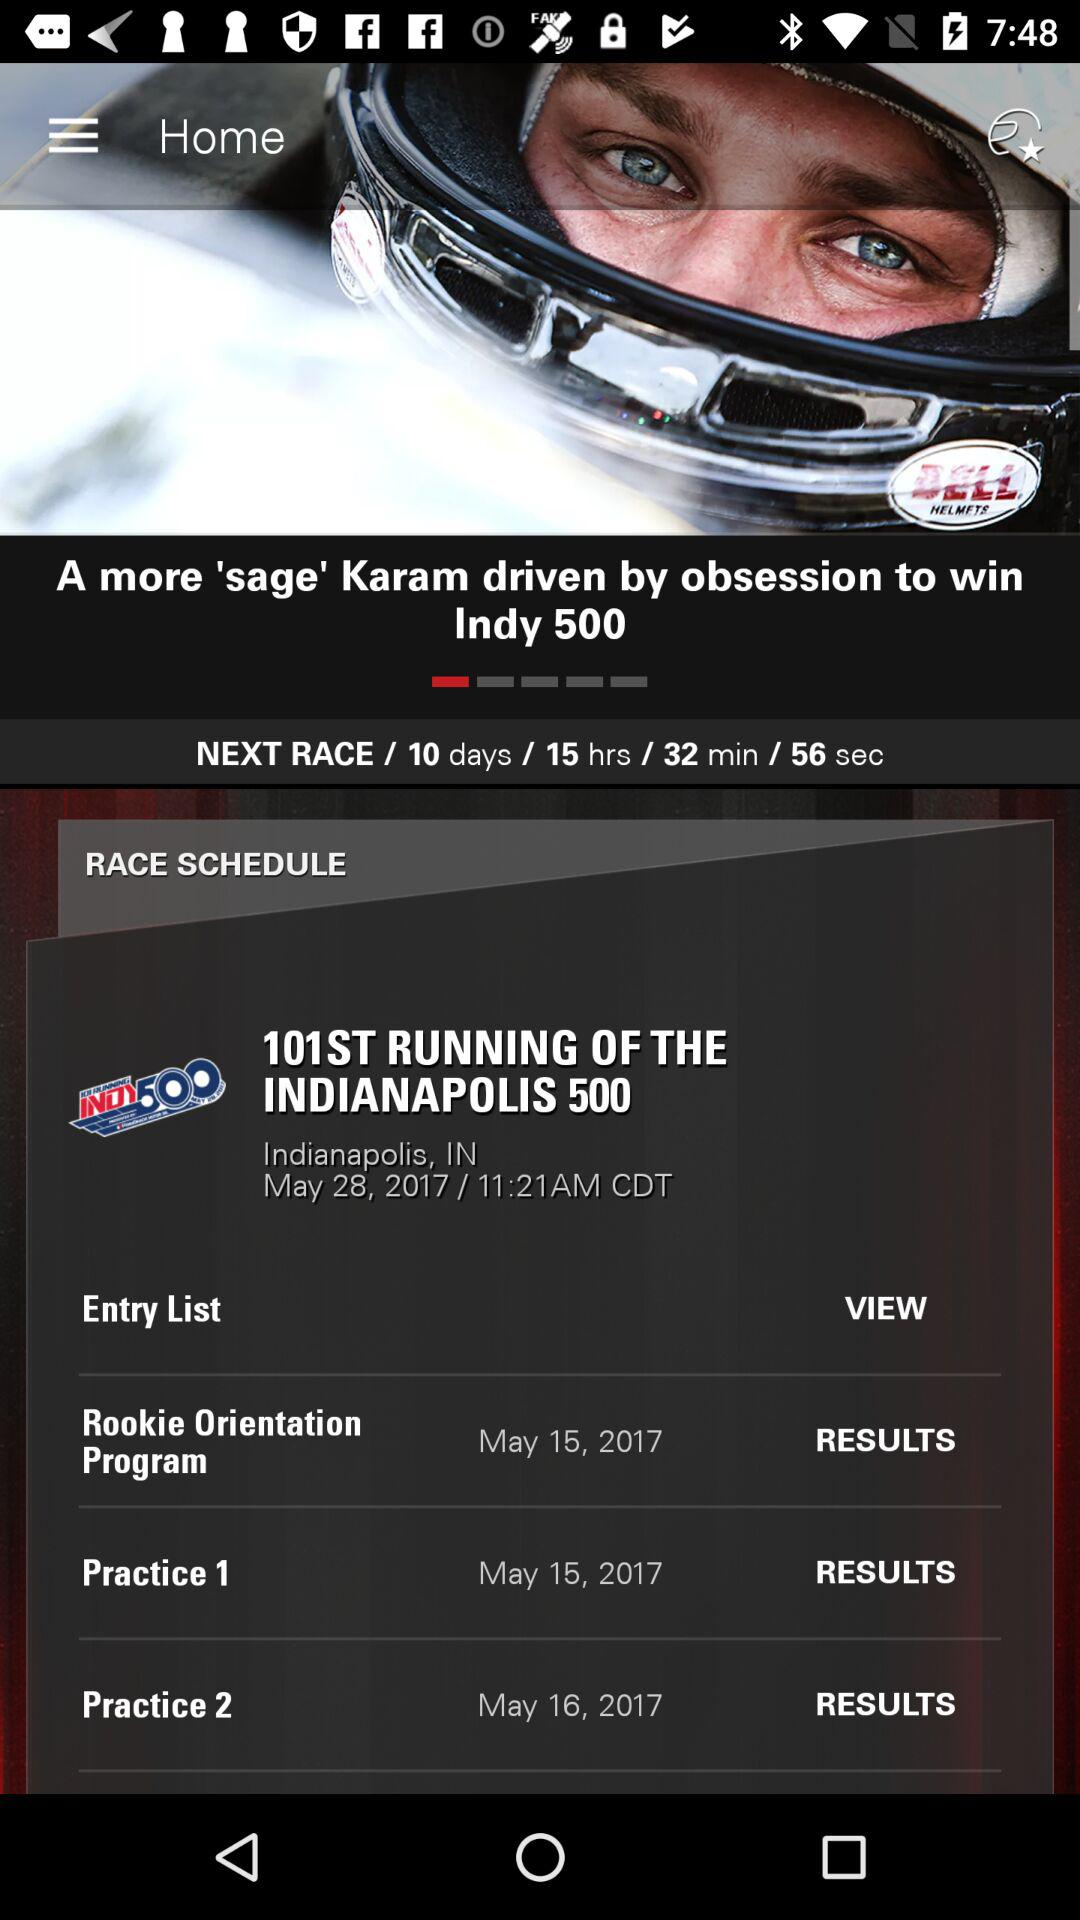On what date did the "101ST RUNNING OF THE INDIANAPLOIS 500" race happen? The race happened on May 28, 2017. 